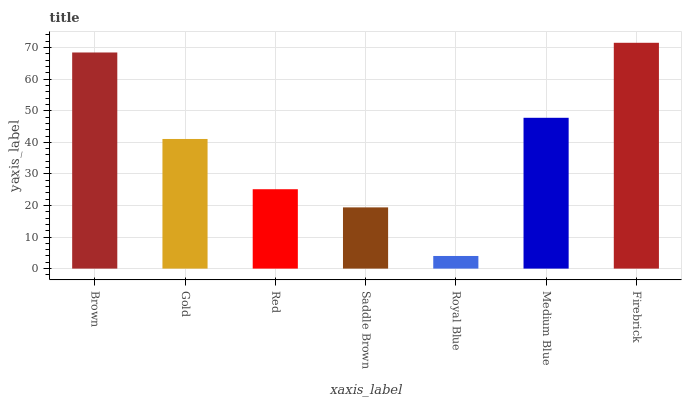Is Royal Blue the minimum?
Answer yes or no. Yes. Is Firebrick the maximum?
Answer yes or no. Yes. Is Gold the minimum?
Answer yes or no. No. Is Gold the maximum?
Answer yes or no. No. Is Brown greater than Gold?
Answer yes or no. Yes. Is Gold less than Brown?
Answer yes or no. Yes. Is Gold greater than Brown?
Answer yes or no. No. Is Brown less than Gold?
Answer yes or no. No. Is Gold the high median?
Answer yes or no. Yes. Is Gold the low median?
Answer yes or no. Yes. Is Saddle Brown the high median?
Answer yes or no. No. Is Red the low median?
Answer yes or no. No. 